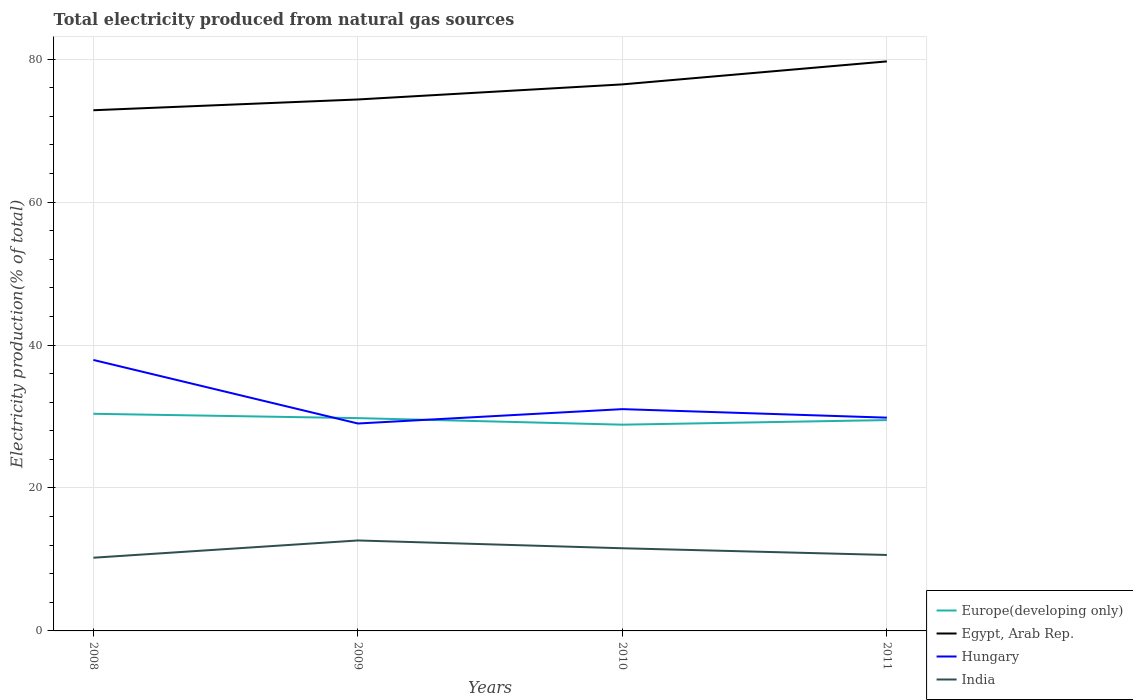How many different coloured lines are there?
Make the answer very short. 4. Is the number of lines equal to the number of legend labels?
Keep it short and to the point. Yes. Across all years, what is the maximum total electricity produced in Hungary?
Your answer should be compact. 29.02. What is the total total electricity produced in Hungary in the graph?
Make the answer very short. 1.19. What is the difference between the highest and the second highest total electricity produced in Hungary?
Provide a short and direct response. 8.89. How many years are there in the graph?
Keep it short and to the point. 4. What is the difference between two consecutive major ticks on the Y-axis?
Make the answer very short. 20. Where does the legend appear in the graph?
Your response must be concise. Bottom right. What is the title of the graph?
Offer a very short reply. Total electricity produced from natural gas sources. Does "Libya" appear as one of the legend labels in the graph?
Keep it short and to the point. No. What is the label or title of the X-axis?
Offer a very short reply. Years. What is the label or title of the Y-axis?
Your response must be concise. Electricity production(% of total). What is the Electricity production(% of total) of Europe(developing only) in 2008?
Provide a short and direct response. 30.38. What is the Electricity production(% of total) in Egypt, Arab Rep. in 2008?
Your answer should be compact. 72.86. What is the Electricity production(% of total) in Hungary in 2008?
Provide a succinct answer. 37.92. What is the Electricity production(% of total) in India in 2008?
Offer a terse response. 10.24. What is the Electricity production(% of total) of Europe(developing only) in 2009?
Provide a short and direct response. 29.78. What is the Electricity production(% of total) of Egypt, Arab Rep. in 2009?
Offer a very short reply. 74.37. What is the Electricity production(% of total) of Hungary in 2009?
Keep it short and to the point. 29.02. What is the Electricity production(% of total) of India in 2009?
Give a very brief answer. 12.66. What is the Electricity production(% of total) in Europe(developing only) in 2010?
Your answer should be very brief. 28.86. What is the Electricity production(% of total) in Egypt, Arab Rep. in 2010?
Provide a short and direct response. 76.48. What is the Electricity production(% of total) in Hungary in 2010?
Keep it short and to the point. 31.03. What is the Electricity production(% of total) of India in 2010?
Your answer should be compact. 11.57. What is the Electricity production(% of total) in Europe(developing only) in 2011?
Ensure brevity in your answer.  29.5. What is the Electricity production(% of total) of Egypt, Arab Rep. in 2011?
Keep it short and to the point. 79.69. What is the Electricity production(% of total) of Hungary in 2011?
Offer a terse response. 29.84. What is the Electricity production(% of total) of India in 2011?
Provide a succinct answer. 10.63. Across all years, what is the maximum Electricity production(% of total) in Europe(developing only)?
Offer a very short reply. 30.38. Across all years, what is the maximum Electricity production(% of total) in Egypt, Arab Rep.?
Your answer should be compact. 79.69. Across all years, what is the maximum Electricity production(% of total) of Hungary?
Your answer should be very brief. 37.92. Across all years, what is the maximum Electricity production(% of total) of India?
Your answer should be compact. 12.66. Across all years, what is the minimum Electricity production(% of total) in Europe(developing only)?
Offer a terse response. 28.86. Across all years, what is the minimum Electricity production(% of total) of Egypt, Arab Rep.?
Provide a short and direct response. 72.86. Across all years, what is the minimum Electricity production(% of total) of Hungary?
Offer a very short reply. 29.02. Across all years, what is the minimum Electricity production(% of total) of India?
Your answer should be very brief. 10.24. What is the total Electricity production(% of total) of Europe(developing only) in the graph?
Your answer should be very brief. 118.52. What is the total Electricity production(% of total) in Egypt, Arab Rep. in the graph?
Your response must be concise. 303.4. What is the total Electricity production(% of total) of Hungary in the graph?
Offer a very short reply. 127.82. What is the total Electricity production(% of total) of India in the graph?
Your response must be concise. 45.1. What is the difference between the Electricity production(% of total) in Europe(developing only) in 2008 and that in 2009?
Offer a terse response. 0.61. What is the difference between the Electricity production(% of total) in Egypt, Arab Rep. in 2008 and that in 2009?
Keep it short and to the point. -1.51. What is the difference between the Electricity production(% of total) in Hungary in 2008 and that in 2009?
Your response must be concise. 8.89. What is the difference between the Electricity production(% of total) of India in 2008 and that in 2009?
Ensure brevity in your answer.  -2.41. What is the difference between the Electricity production(% of total) in Europe(developing only) in 2008 and that in 2010?
Make the answer very short. 1.53. What is the difference between the Electricity production(% of total) in Egypt, Arab Rep. in 2008 and that in 2010?
Offer a terse response. -3.62. What is the difference between the Electricity production(% of total) of Hungary in 2008 and that in 2010?
Make the answer very short. 6.88. What is the difference between the Electricity production(% of total) in India in 2008 and that in 2010?
Your answer should be compact. -1.32. What is the difference between the Electricity production(% of total) of Europe(developing only) in 2008 and that in 2011?
Your answer should be compact. 0.88. What is the difference between the Electricity production(% of total) of Egypt, Arab Rep. in 2008 and that in 2011?
Your response must be concise. -6.83. What is the difference between the Electricity production(% of total) in Hungary in 2008 and that in 2011?
Ensure brevity in your answer.  8.07. What is the difference between the Electricity production(% of total) of India in 2008 and that in 2011?
Your answer should be very brief. -0.38. What is the difference between the Electricity production(% of total) of Europe(developing only) in 2009 and that in 2010?
Your response must be concise. 0.92. What is the difference between the Electricity production(% of total) of Egypt, Arab Rep. in 2009 and that in 2010?
Make the answer very short. -2.11. What is the difference between the Electricity production(% of total) of Hungary in 2009 and that in 2010?
Your answer should be compact. -2.01. What is the difference between the Electricity production(% of total) in India in 2009 and that in 2010?
Make the answer very short. 1.09. What is the difference between the Electricity production(% of total) of Europe(developing only) in 2009 and that in 2011?
Your response must be concise. 0.27. What is the difference between the Electricity production(% of total) in Egypt, Arab Rep. in 2009 and that in 2011?
Keep it short and to the point. -5.33. What is the difference between the Electricity production(% of total) of Hungary in 2009 and that in 2011?
Offer a terse response. -0.82. What is the difference between the Electricity production(% of total) in India in 2009 and that in 2011?
Provide a succinct answer. 2.03. What is the difference between the Electricity production(% of total) in Europe(developing only) in 2010 and that in 2011?
Offer a very short reply. -0.64. What is the difference between the Electricity production(% of total) of Egypt, Arab Rep. in 2010 and that in 2011?
Your answer should be very brief. -3.22. What is the difference between the Electricity production(% of total) in Hungary in 2010 and that in 2011?
Your answer should be compact. 1.19. What is the difference between the Electricity production(% of total) of India in 2010 and that in 2011?
Offer a very short reply. 0.94. What is the difference between the Electricity production(% of total) in Europe(developing only) in 2008 and the Electricity production(% of total) in Egypt, Arab Rep. in 2009?
Give a very brief answer. -43.98. What is the difference between the Electricity production(% of total) in Europe(developing only) in 2008 and the Electricity production(% of total) in Hungary in 2009?
Your response must be concise. 1.36. What is the difference between the Electricity production(% of total) in Europe(developing only) in 2008 and the Electricity production(% of total) in India in 2009?
Keep it short and to the point. 17.73. What is the difference between the Electricity production(% of total) in Egypt, Arab Rep. in 2008 and the Electricity production(% of total) in Hungary in 2009?
Your answer should be compact. 43.84. What is the difference between the Electricity production(% of total) of Egypt, Arab Rep. in 2008 and the Electricity production(% of total) of India in 2009?
Keep it short and to the point. 60.2. What is the difference between the Electricity production(% of total) of Hungary in 2008 and the Electricity production(% of total) of India in 2009?
Your answer should be very brief. 25.26. What is the difference between the Electricity production(% of total) of Europe(developing only) in 2008 and the Electricity production(% of total) of Egypt, Arab Rep. in 2010?
Make the answer very short. -46.09. What is the difference between the Electricity production(% of total) of Europe(developing only) in 2008 and the Electricity production(% of total) of Hungary in 2010?
Make the answer very short. -0.65. What is the difference between the Electricity production(% of total) in Europe(developing only) in 2008 and the Electricity production(% of total) in India in 2010?
Your answer should be compact. 18.82. What is the difference between the Electricity production(% of total) in Egypt, Arab Rep. in 2008 and the Electricity production(% of total) in Hungary in 2010?
Offer a terse response. 41.82. What is the difference between the Electricity production(% of total) of Egypt, Arab Rep. in 2008 and the Electricity production(% of total) of India in 2010?
Offer a terse response. 61.29. What is the difference between the Electricity production(% of total) of Hungary in 2008 and the Electricity production(% of total) of India in 2010?
Offer a very short reply. 26.35. What is the difference between the Electricity production(% of total) of Europe(developing only) in 2008 and the Electricity production(% of total) of Egypt, Arab Rep. in 2011?
Offer a terse response. -49.31. What is the difference between the Electricity production(% of total) of Europe(developing only) in 2008 and the Electricity production(% of total) of Hungary in 2011?
Ensure brevity in your answer.  0.54. What is the difference between the Electricity production(% of total) in Europe(developing only) in 2008 and the Electricity production(% of total) in India in 2011?
Your answer should be very brief. 19.76. What is the difference between the Electricity production(% of total) in Egypt, Arab Rep. in 2008 and the Electricity production(% of total) in Hungary in 2011?
Make the answer very short. 43.02. What is the difference between the Electricity production(% of total) of Egypt, Arab Rep. in 2008 and the Electricity production(% of total) of India in 2011?
Offer a terse response. 62.23. What is the difference between the Electricity production(% of total) of Hungary in 2008 and the Electricity production(% of total) of India in 2011?
Offer a very short reply. 27.29. What is the difference between the Electricity production(% of total) of Europe(developing only) in 2009 and the Electricity production(% of total) of Egypt, Arab Rep. in 2010?
Give a very brief answer. -46.7. What is the difference between the Electricity production(% of total) of Europe(developing only) in 2009 and the Electricity production(% of total) of Hungary in 2010?
Provide a succinct answer. -1.26. What is the difference between the Electricity production(% of total) of Europe(developing only) in 2009 and the Electricity production(% of total) of India in 2010?
Offer a very short reply. 18.21. What is the difference between the Electricity production(% of total) in Egypt, Arab Rep. in 2009 and the Electricity production(% of total) in Hungary in 2010?
Keep it short and to the point. 43.33. What is the difference between the Electricity production(% of total) in Egypt, Arab Rep. in 2009 and the Electricity production(% of total) in India in 2010?
Offer a very short reply. 62.8. What is the difference between the Electricity production(% of total) of Hungary in 2009 and the Electricity production(% of total) of India in 2010?
Make the answer very short. 17.46. What is the difference between the Electricity production(% of total) of Europe(developing only) in 2009 and the Electricity production(% of total) of Egypt, Arab Rep. in 2011?
Make the answer very short. -49.92. What is the difference between the Electricity production(% of total) in Europe(developing only) in 2009 and the Electricity production(% of total) in Hungary in 2011?
Make the answer very short. -0.06. What is the difference between the Electricity production(% of total) in Europe(developing only) in 2009 and the Electricity production(% of total) in India in 2011?
Provide a short and direct response. 19.15. What is the difference between the Electricity production(% of total) of Egypt, Arab Rep. in 2009 and the Electricity production(% of total) of Hungary in 2011?
Make the answer very short. 44.52. What is the difference between the Electricity production(% of total) in Egypt, Arab Rep. in 2009 and the Electricity production(% of total) in India in 2011?
Your response must be concise. 63.74. What is the difference between the Electricity production(% of total) in Hungary in 2009 and the Electricity production(% of total) in India in 2011?
Provide a succinct answer. 18.4. What is the difference between the Electricity production(% of total) of Europe(developing only) in 2010 and the Electricity production(% of total) of Egypt, Arab Rep. in 2011?
Offer a terse response. -50.83. What is the difference between the Electricity production(% of total) of Europe(developing only) in 2010 and the Electricity production(% of total) of Hungary in 2011?
Make the answer very short. -0.98. What is the difference between the Electricity production(% of total) of Europe(developing only) in 2010 and the Electricity production(% of total) of India in 2011?
Provide a short and direct response. 18.23. What is the difference between the Electricity production(% of total) in Egypt, Arab Rep. in 2010 and the Electricity production(% of total) in Hungary in 2011?
Keep it short and to the point. 46.63. What is the difference between the Electricity production(% of total) of Egypt, Arab Rep. in 2010 and the Electricity production(% of total) of India in 2011?
Your response must be concise. 65.85. What is the difference between the Electricity production(% of total) in Hungary in 2010 and the Electricity production(% of total) in India in 2011?
Give a very brief answer. 20.41. What is the average Electricity production(% of total) in Europe(developing only) per year?
Provide a succinct answer. 29.63. What is the average Electricity production(% of total) of Egypt, Arab Rep. per year?
Give a very brief answer. 75.85. What is the average Electricity production(% of total) of Hungary per year?
Offer a terse response. 31.95. What is the average Electricity production(% of total) of India per year?
Provide a succinct answer. 11.27. In the year 2008, what is the difference between the Electricity production(% of total) of Europe(developing only) and Electricity production(% of total) of Egypt, Arab Rep.?
Offer a terse response. -42.47. In the year 2008, what is the difference between the Electricity production(% of total) in Europe(developing only) and Electricity production(% of total) in Hungary?
Your answer should be very brief. -7.53. In the year 2008, what is the difference between the Electricity production(% of total) in Europe(developing only) and Electricity production(% of total) in India?
Your answer should be very brief. 20.14. In the year 2008, what is the difference between the Electricity production(% of total) of Egypt, Arab Rep. and Electricity production(% of total) of Hungary?
Make the answer very short. 34.94. In the year 2008, what is the difference between the Electricity production(% of total) of Egypt, Arab Rep. and Electricity production(% of total) of India?
Give a very brief answer. 62.62. In the year 2008, what is the difference between the Electricity production(% of total) in Hungary and Electricity production(% of total) in India?
Your response must be concise. 27.67. In the year 2009, what is the difference between the Electricity production(% of total) of Europe(developing only) and Electricity production(% of total) of Egypt, Arab Rep.?
Your response must be concise. -44.59. In the year 2009, what is the difference between the Electricity production(% of total) in Europe(developing only) and Electricity production(% of total) in Hungary?
Ensure brevity in your answer.  0.75. In the year 2009, what is the difference between the Electricity production(% of total) in Europe(developing only) and Electricity production(% of total) in India?
Offer a terse response. 17.12. In the year 2009, what is the difference between the Electricity production(% of total) in Egypt, Arab Rep. and Electricity production(% of total) in Hungary?
Ensure brevity in your answer.  45.34. In the year 2009, what is the difference between the Electricity production(% of total) in Egypt, Arab Rep. and Electricity production(% of total) in India?
Your answer should be very brief. 61.71. In the year 2009, what is the difference between the Electricity production(% of total) in Hungary and Electricity production(% of total) in India?
Your response must be concise. 16.37. In the year 2010, what is the difference between the Electricity production(% of total) of Europe(developing only) and Electricity production(% of total) of Egypt, Arab Rep.?
Your response must be concise. -47.62. In the year 2010, what is the difference between the Electricity production(% of total) in Europe(developing only) and Electricity production(% of total) in Hungary?
Your response must be concise. -2.18. In the year 2010, what is the difference between the Electricity production(% of total) in Europe(developing only) and Electricity production(% of total) in India?
Give a very brief answer. 17.29. In the year 2010, what is the difference between the Electricity production(% of total) in Egypt, Arab Rep. and Electricity production(% of total) in Hungary?
Your answer should be compact. 45.44. In the year 2010, what is the difference between the Electricity production(% of total) of Egypt, Arab Rep. and Electricity production(% of total) of India?
Your answer should be compact. 64.91. In the year 2010, what is the difference between the Electricity production(% of total) of Hungary and Electricity production(% of total) of India?
Offer a very short reply. 19.47. In the year 2011, what is the difference between the Electricity production(% of total) in Europe(developing only) and Electricity production(% of total) in Egypt, Arab Rep.?
Provide a succinct answer. -50.19. In the year 2011, what is the difference between the Electricity production(% of total) of Europe(developing only) and Electricity production(% of total) of Hungary?
Offer a terse response. -0.34. In the year 2011, what is the difference between the Electricity production(% of total) in Europe(developing only) and Electricity production(% of total) in India?
Make the answer very short. 18.88. In the year 2011, what is the difference between the Electricity production(% of total) of Egypt, Arab Rep. and Electricity production(% of total) of Hungary?
Your answer should be very brief. 49.85. In the year 2011, what is the difference between the Electricity production(% of total) of Egypt, Arab Rep. and Electricity production(% of total) of India?
Offer a very short reply. 69.07. In the year 2011, what is the difference between the Electricity production(% of total) in Hungary and Electricity production(% of total) in India?
Ensure brevity in your answer.  19.21. What is the ratio of the Electricity production(% of total) in Europe(developing only) in 2008 to that in 2009?
Offer a very short reply. 1.02. What is the ratio of the Electricity production(% of total) of Egypt, Arab Rep. in 2008 to that in 2009?
Keep it short and to the point. 0.98. What is the ratio of the Electricity production(% of total) in Hungary in 2008 to that in 2009?
Offer a very short reply. 1.31. What is the ratio of the Electricity production(% of total) of India in 2008 to that in 2009?
Ensure brevity in your answer.  0.81. What is the ratio of the Electricity production(% of total) of Europe(developing only) in 2008 to that in 2010?
Make the answer very short. 1.05. What is the ratio of the Electricity production(% of total) in Egypt, Arab Rep. in 2008 to that in 2010?
Give a very brief answer. 0.95. What is the ratio of the Electricity production(% of total) of Hungary in 2008 to that in 2010?
Keep it short and to the point. 1.22. What is the ratio of the Electricity production(% of total) in India in 2008 to that in 2010?
Give a very brief answer. 0.89. What is the ratio of the Electricity production(% of total) in Europe(developing only) in 2008 to that in 2011?
Offer a terse response. 1.03. What is the ratio of the Electricity production(% of total) in Egypt, Arab Rep. in 2008 to that in 2011?
Provide a short and direct response. 0.91. What is the ratio of the Electricity production(% of total) of Hungary in 2008 to that in 2011?
Make the answer very short. 1.27. What is the ratio of the Electricity production(% of total) of India in 2008 to that in 2011?
Your answer should be compact. 0.96. What is the ratio of the Electricity production(% of total) of Europe(developing only) in 2009 to that in 2010?
Keep it short and to the point. 1.03. What is the ratio of the Electricity production(% of total) of Egypt, Arab Rep. in 2009 to that in 2010?
Give a very brief answer. 0.97. What is the ratio of the Electricity production(% of total) in Hungary in 2009 to that in 2010?
Ensure brevity in your answer.  0.94. What is the ratio of the Electricity production(% of total) of India in 2009 to that in 2010?
Offer a very short reply. 1.09. What is the ratio of the Electricity production(% of total) in Europe(developing only) in 2009 to that in 2011?
Keep it short and to the point. 1.01. What is the ratio of the Electricity production(% of total) of Egypt, Arab Rep. in 2009 to that in 2011?
Provide a succinct answer. 0.93. What is the ratio of the Electricity production(% of total) in Hungary in 2009 to that in 2011?
Offer a very short reply. 0.97. What is the ratio of the Electricity production(% of total) of India in 2009 to that in 2011?
Keep it short and to the point. 1.19. What is the ratio of the Electricity production(% of total) in Europe(developing only) in 2010 to that in 2011?
Give a very brief answer. 0.98. What is the ratio of the Electricity production(% of total) of Egypt, Arab Rep. in 2010 to that in 2011?
Ensure brevity in your answer.  0.96. What is the ratio of the Electricity production(% of total) of Hungary in 2010 to that in 2011?
Your answer should be very brief. 1.04. What is the ratio of the Electricity production(% of total) of India in 2010 to that in 2011?
Keep it short and to the point. 1.09. What is the difference between the highest and the second highest Electricity production(% of total) in Europe(developing only)?
Provide a succinct answer. 0.61. What is the difference between the highest and the second highest Electricity production(% of total) of Egypt, Arab Rep.?
Give a very brief answer. 3.22. What is the difference between the highest and the second highest Electricity production(% of total) of Hungary?
Make the answer very short. 6.88. What is the difference between the highest and the second highest Electricity production(% of total) of India?
Your answer should be compact. 1.09. What is the difference between the highest and the lowest Electricity production(% of total) in Europe(developing only)?
Offer a terse response. 1.53. What is the difference between the highest and the lowest Electricity production(% of total) in Egypt, Arab Rep.?
Your response must be concise. 6.83. What is the difference between the highest and the lowest Electricity production(% of total) of Hungary?
Provide a short and direct response. 8.89. What is the difference between the highest and the lowest Electricity production(% of total) in India?
Your answer should be very brief. 2.41. 